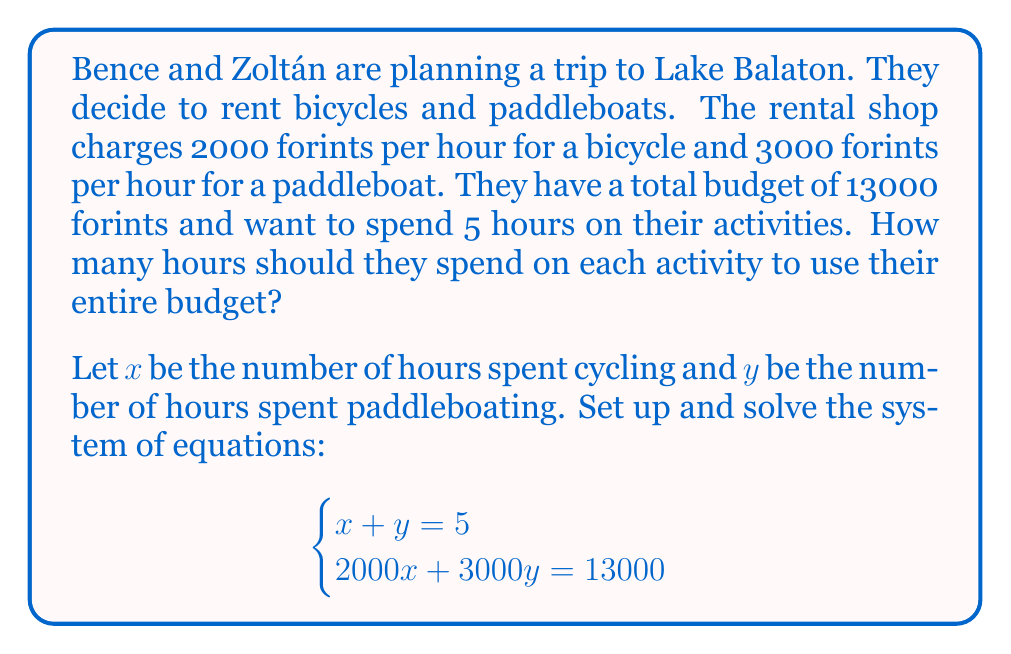Show me your answer to this math problem. Let's solve this system of equations using the substitution method:

1) From the first equation, we can express $x$ in terms of $y$:
   $x + y = 5$
   $x = 5 - y$

2) Substitute this expression for $x$ into the second equation:
   $2000x + 3000y = 13000$
   $2000(5 - y) + 3000y = 13000$

3) Simplify:
   $10000 - 2000y + 3000y = 13000$
   $10000 + 1000y = 13000$

4) Solve for $y$:
   $1000y = 3000$
   $y = 3$

5) Now that we know $y$, we can find $x$ using the equation from step 1:
   $x = 5 - y = 5 - 3 = 2$

6) Verify the solution by substituting back into both original equations:
   $x + y = 2 + 3 = 5$ ✓
   $2000(2) + 3000(3) = 4000 + 9000 = 13000$ ✓

Therefore, Bence and Zoltán should spend 2 hours cycling and 3 hours paddleboating to use their entire budget.
Answer: $x = 2$, $y = 3$
Bence and Zoltán should spend 2 hours cycling and 3 hours paddleboating. 